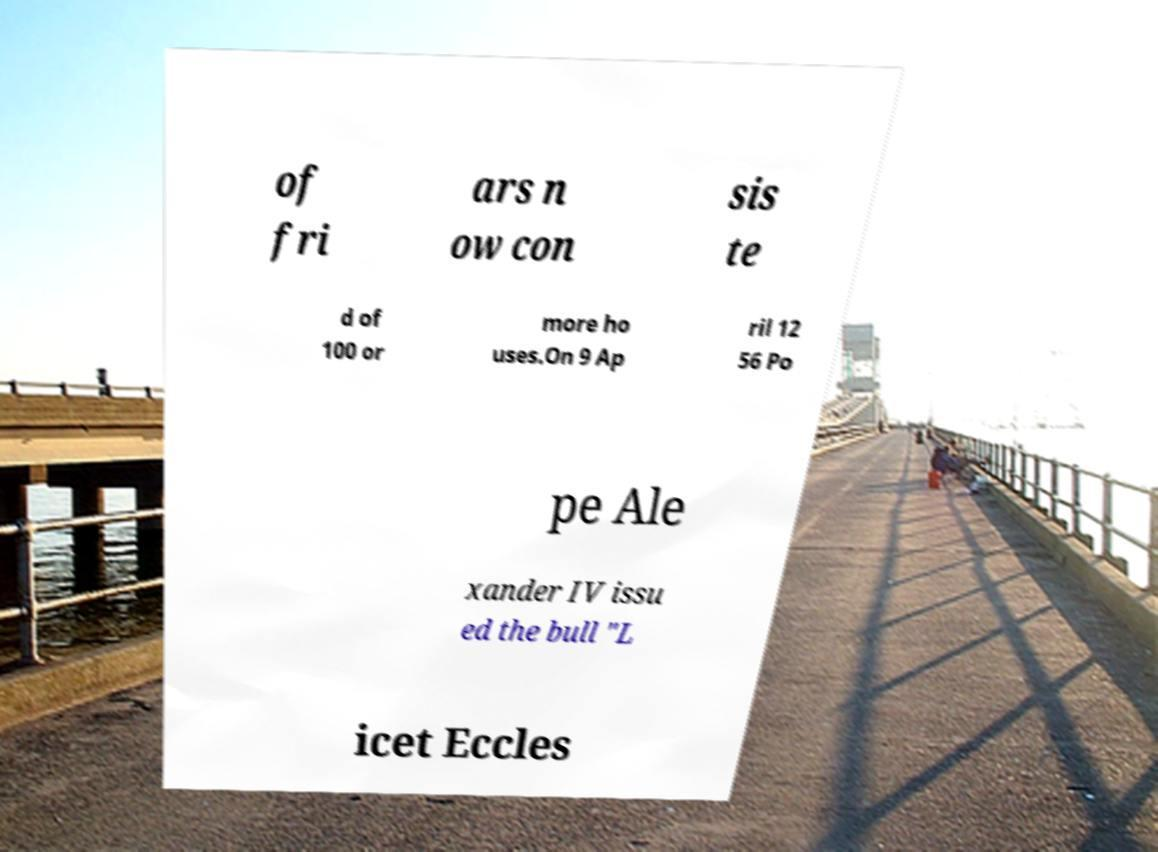Please read and relay the text visible in this image. What does it say? of fri ars n ow con sis te d of 100 or more ho uses.On 9 Ap ril 12 56 Po pe Ale xander IV issu ed the bull "L icet Eccles 